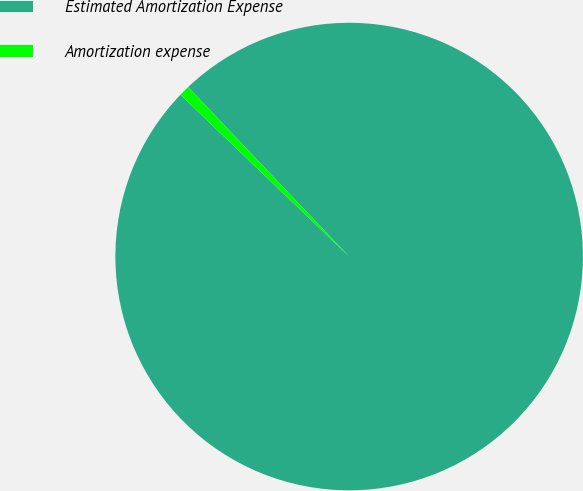Convert chart. <chart><loc_0><loc_0><loc_500><loc_500><pie_chart><fcel>Estimated Amortization Expense<fcel>Amortization expense<nl><fcel>99.26%<fcel>0.74%<nl></chart> 